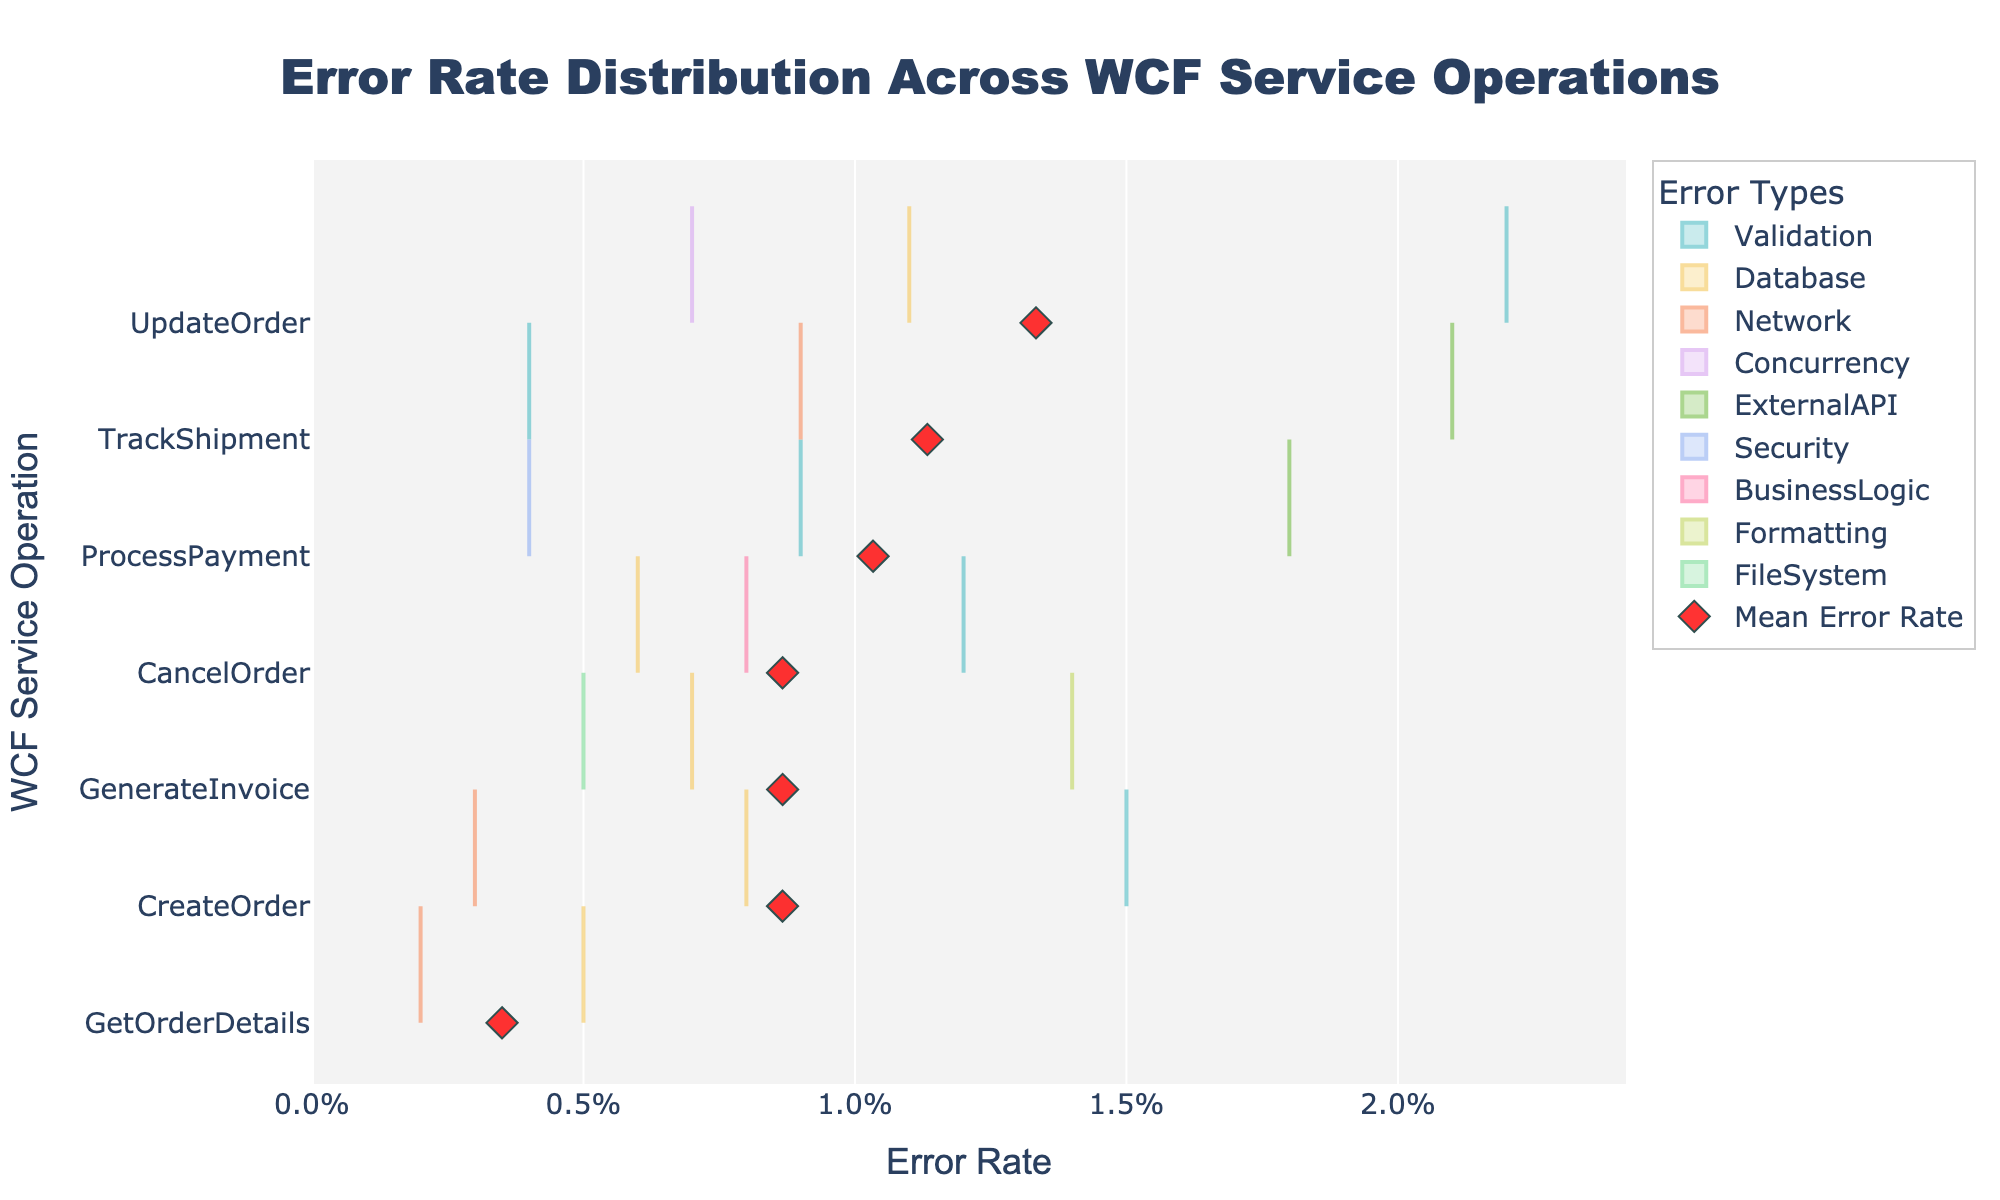Which WCF service operation has the highest mean error rate? By observing the scatter markers that represent the mean error rate for each operation, the operation with the highest scatter marker on the x-axis has the highest mean error rate. The title and axis labels can help identify the mean error rate.
Answer: UpdateOrder Which error type has the widest distribution range in the TrackShipment operation? By looking at the width of the density plot for each error type within the TrackShipment operation, the error type with the widest range spread horizontally is identified. Compare the density plots on the y-axis labeled TrackShipment.
Answer: ExternalAPI What is the most common error type in the CreateOrder operation? By examining the density plot for each error type in the CreateOrder operation, the error type with the highest density (widest and tallest distribution) is the most common. The y-axis labeled CreateOrder will guide us.
Answer: Validation How does the mean error rate of ProcessPayment compare to that of TrackShipment? To compare the mean error rates, observe the positions of the scatter markers for ProcessPayment and TrackShipment on the x-axis. The position farther to the right indicates a higher mean error rate.
Answer: TrackShipment has a higher mean error rate than ProcessPayment What error types are represented in the GenerateInvoice operation, and what are their error rates? By identifying the distinct density plots for the GenerateInvoice operation on the y-axis, the error types and the x-axis values for each density plot will provide the error rates.
Answer: Formatting: 0.014, Database: 0.007, FileSystem: 0.005 Which WCF service operation has the most diverse error types? By counting the different colored density plots for each operation, the operation with the highest number of unique colors (representing error types) has the most diverse error types.
Answer: ProcessPayment and TrackShipment (both have three error types) Which error type is unique to the CancelOrder operation? By examining the different error types plotted for each operation, identify any error type that appears only under the CancelOrder operation on the y-axis.
Answer: BusinessLogic What is the sum of the error rates for all error types in the GetOrderDetails operation? Add the x-axis values (error rates) of each error type for the GetOrderDetails operation to find the sum. Recall the densities: Database: 0.005 + Network: 0.002 = 0.007
Answer: 0.007 Is the Validation error type present in all operations? Check each operation on the y-axis and determine if a density plot colored for Validation error is present. Validation errors will be identified by their consistent color across the operations.
Answer: No Which operation shows a mean error rate marker farther to the right, GenerateInvoice or TrackShipment? Locate the mean error rate markers (scatter) for GenerateInvoice and TrackShipment on the x-axis; the one farther to the right has a higher mean error rate.
Answer: TrackShipment 